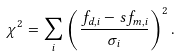Convert formula to latex. <formula><loc_0><loc_0><loc_500><loc_500>\chi ^ { 2 } = \sum _ { i } \left ( \frac { f _ { d , i } - s f _ { m , i } } { \sigma _ { i } } \right ) ^ { 2 } .</formula> 